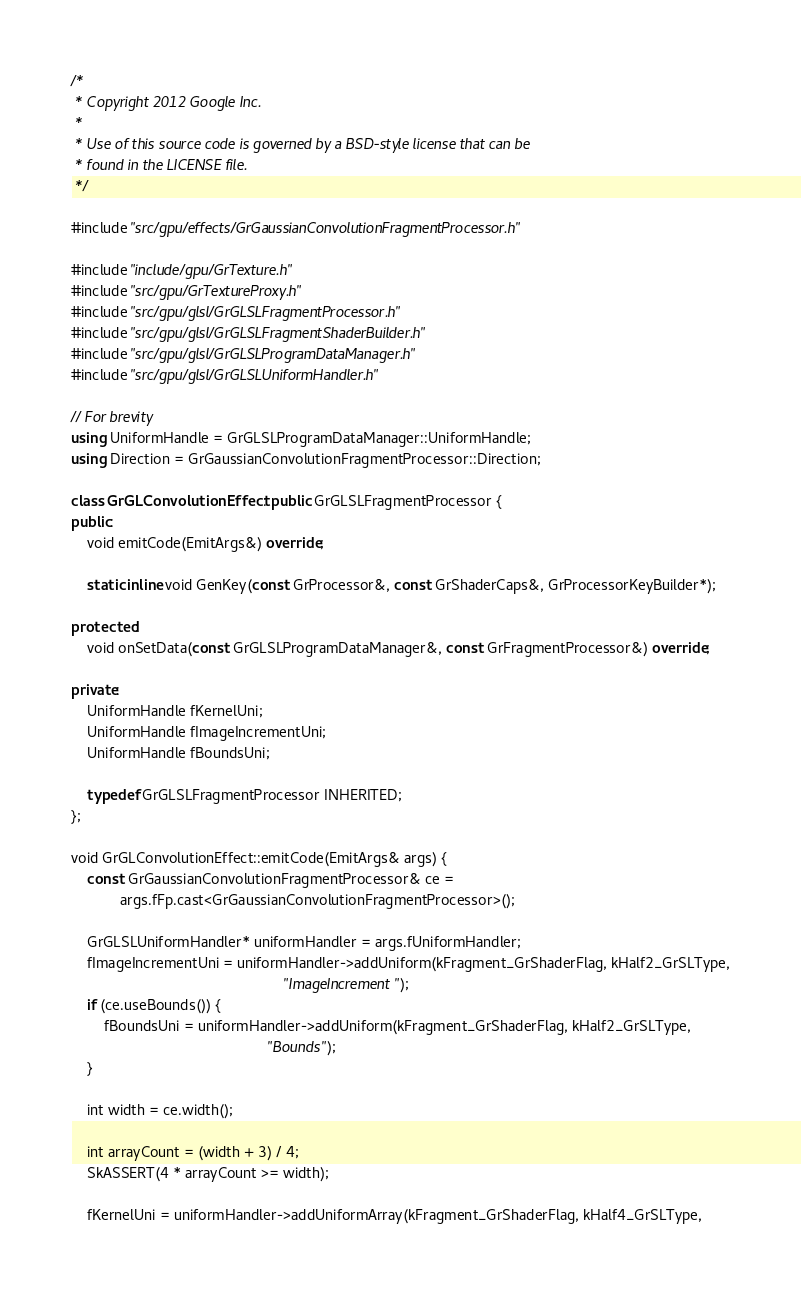<code> <loc_0><loc_0><loc_500><loc_500><_C++_>/*
 * Copyright 2012 Google Inc.
 *
 * Use of this source code is governed by a BSD-style license that can be
 * found in the LICENSE file.
 */

#include "src/gpu/effects/GrGaussianConvolutionFragmentProcessor.h"

#include "include/gpu/GrTexture.h"
#include "src/gpu/GrTextureProxy.h"
#include "src/gpu/glsl/GrGLSLFragmentProcessor.h"
#include "src/gpu/glsl/GrGLSLFragmentShaderBuilder.h"
#include "src/gpu/glsl/GrGLSLProgramDataManager.h"
#include "src/gpu/glsl/GrGLSLUniformHandler.h"

// For brevity
using UniformHandle = GrGLSLProgramDataManager::UniformHandle;
using Direction = GrGaussianConvolutionFragmentProcessor::Direction;

class GrGLConvolutionEffect : public GrGLSLFragmentProcessor {
public:
    void emitCode(EmitArgs&) override;

    static inline void GenKey(const GrProcessor&, const GrShaderCaps&, GrProcessorKeyBuilder*);

protected:
    void onSetData(const GrGLSLProgramDataManager&, const GrFragmentProcessor&) override;

private:
    UniformHandle fKernelUni;
    UniformHandle fImageIncrementUni;
    UniformHandle fBoundsUni;

    typedef GrGLSLFragmentProcessor INHERITED;
};

void GrGLConvolutionEffect::emitCode(EmitArgs& args) {
    const GrGaussianConvolutionFragmentProcessor& ce =
            args.fFp.cast<GrGaussianConvolutionFragmentProcessor>();

    GrGLSLUniformHandler* uniformHandler = args.fUniformHandler;
    fImageIncrementUni = uniformHandler->addUniform(kFragment_GrShaderFlag, kHalf2_GrSLType,
                                                    "ImageIncrement");
    if (ce.useBounds()) {
        fBoundsUni = uniformHandler->addUniform(kFragment_GrShaderFlag, kHalf2_GrSLType,
                                                "Bounds");
    }

    int width = ce.width();

    int arrayCount = (width + 3) / 4;
    SkASSERT(4 * arrayCount >= width);

    fKernelUni = uniformHandler->addUniformArray(kFragment_GrShaderFlag, kHalf4_GrSLType,</code> 